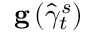<formula> <loc_0><loc_0><loc_500><loc_500>g \left ( \widehat { \gamma } _ { t } ^ { s } \right )</formula> 